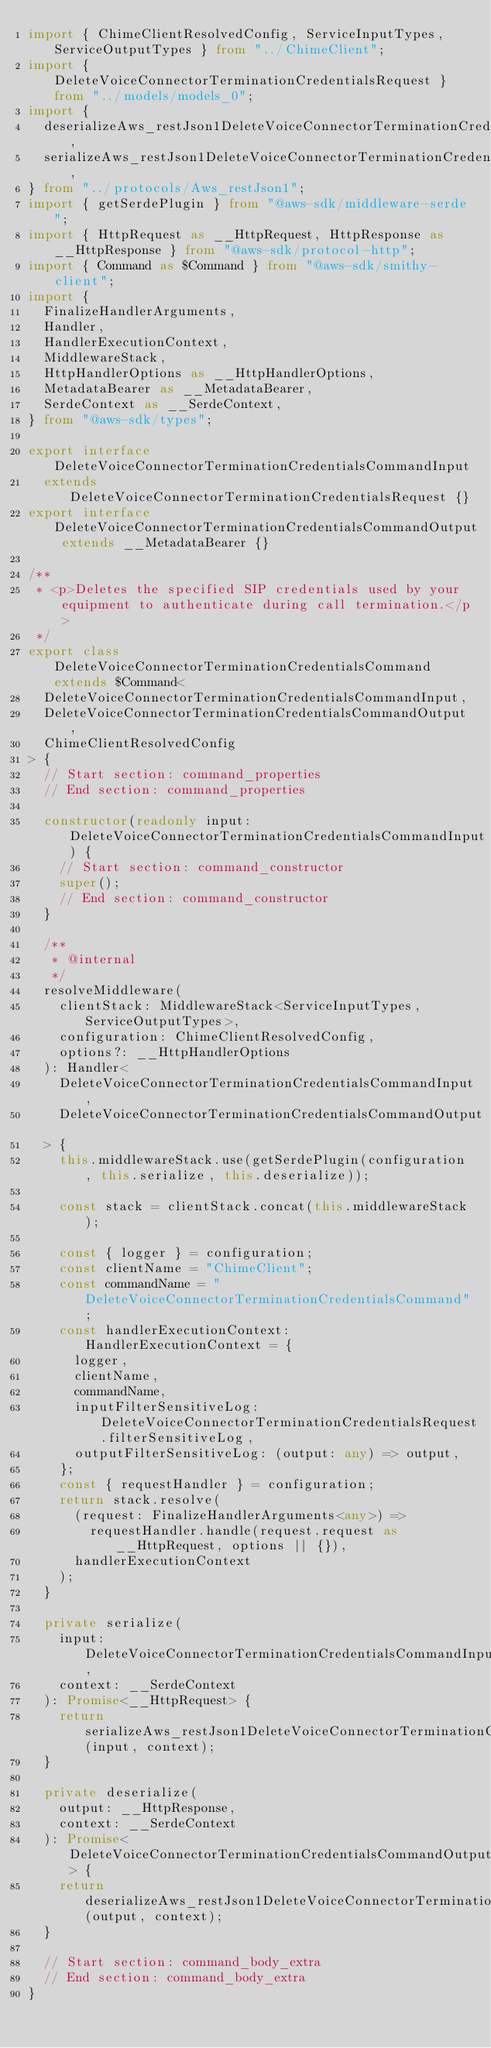<code> <loc_0><loc_0><loc_500><loc_500><_TypeScript_>import { ChimeClientResolvedConfig, ServiceInputTypes, ServiceOutputTypes } from "../ChimeClient";
import { DeleteVoiceConnectorTerminationCredentialsRequest } from "../models/models_0";
import {
  deserializeAws_restJson1DeleteVoiceConnectorTerminationCredentialsCommand,
  serializeAws_restJson1DeleteVoiceConnectorTerminationCredentialsCommand,
} from "../protocols/Aws_restJson1";
import { getSerdePlugin } from "@aws-sdk/middleware-serde";
import { HttpRequest as __HttpRequest, HttpResponse as __HttpResponse } from "@aws-sdk/protocol-http";
import { Command as $Command } from "@aws-sdk/smithy-client";
import {
  FinalizeHandlerArguments,
  Handler,
  HandlerExecutionContext,
  MiddlewareStack,
  HttpHandlerOptions as __HttpHandlerOptions,
  MetadataBearer as __MetadataBearer,
  SerdeContext as __SerdeContext,
} from "@aws-sdk/types";

export interface DeleteVoiceConnectorTerminationCredentialsCommandInput
  extends DeleteVoiceConnectorTerminationCredentialsRequest {}
export interface DeleteVoiceConnectorTerminationCredentialsCommandOutput extends __MetadataBearer {}

/**
 * <p>Deletes the specified SIP credentials used by your equipment to authenticate during call termination.</p>
 */
export class DeleteVoiceConnectorTerminationCredentialsCommand extends $Command<
  DeleteVoiceConnectorTerminationCredentialsCommandInput,
  DeleteVoiceConnectorTerminationCredentialsCommandOutput,
  ChimeClientResolvedConfig
> {
  // Start section: command_properties
  // End section: command_properties

  constructor(readonly input: DeleteVoiceConnectorTerminationCredentialsCommandInput) {
    // Start section: command_constructor
    super();
    // End section: command_constructor
  }

  /**
   * @internal
   */
  resolveMiddleware(
    clientStack: MiddlewareStack<ServiceInputTypes, ServiceOutputTypes>,
    configuration: ChimeClientResolvedConfig,
    options?: __HttpHandlerOptions
  ): Handler<
    DeleteVoiceConnectorTerminationCredentialsCommandInput,
    DeleteVoiceConnectorTerminationCredentialsCommandOutput
  > {
    this.middlewareStack.use(getSerdePlugin(configuration, this.serialize, this.deserialize));

    const stack = clientStack.concat(this.middlewareStack);

    const { logger } = configuration;
    const clientName = "ChimeClient";
    const commandName = "DeleteVoiceConnectorTerminationCredentialsCommand";
    const handlerExecutionContext: HandlerExecutionContext = {
      logger,
      clientName,
      commandName,
      inputFilterSensitiveLog: DeleteVoiceConnectorTerminationCredentialsRequest.filterSensitiveLog,
      outputFilterSensitiveLog: (output: any) => output,
    };
    const { requestHandler } = configuration;
    return stack.resolve(
      (request: FinalizeHandlerArguments<any>) =>
        requestHandler.handle(request.request as __HttpRequest, options || {}),
      handlerExecutionContext
    );
  }

  private serialize(
    input: DeleteVoiceConnectorTerminationCredentialsCommandInput,
    context: __SerdeContext
  ): Promise<__HttpRequest> {
    return serializeAws_restJson1DeleteVoiceConnectorTerminationCredentialsCommand(input, context);
  }

  private deserialize(
    output: __HttpResponse,
    context: __SerdeContext
  ): Promise<DeleteVoiceConnectorTerminationCredentialsCommandOutput> {
    return deserializeAws_restJson1DeleteVoiceConnectorTerminationCredentialsCommand(output, context);
  }

  // Start section: command_body_extra
  // End section: command_body_extra
}
</code> 